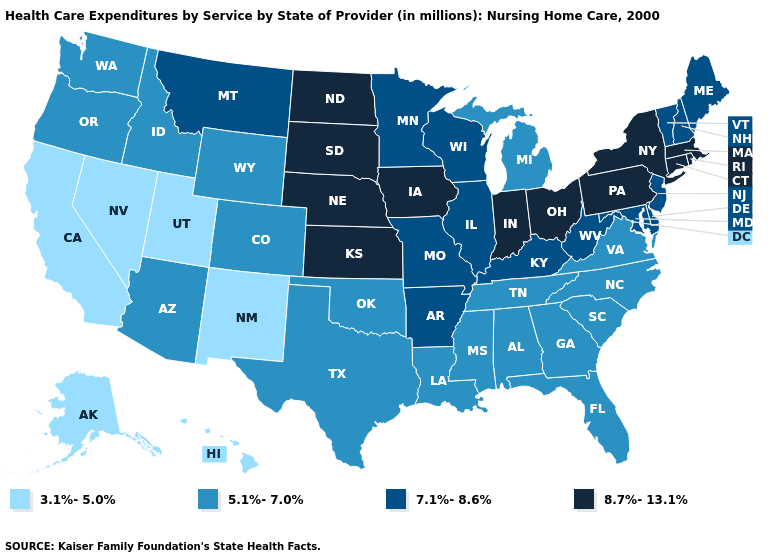How many symbols are there in the legend?
Keep it brief. 4. What is the value of South Dakota?
Concise answer only. 8.7%-13.1%. Does the map have missing data?
Quick response, please. No. Name the states that have a value in the range 8.7%-13.1%?
Keep it brief. Connecticut, Indiana, Iowa, Kansas, Massachusetts, Nebraska, New York, North Dakota, Ohio, Pennsylvania, Rhode Island, South Dakota. What is the value of Alaska?
Be succinct. 3.1%-5.0%. What is the highest value in the MidWest ?
Write a very short answer. 8.7%-13.1%. Does the first symbol in the legend represent the smallest category?
Give a very brief answer. Yes. Does the map have missing data?
Concise answer only. No. Does Rhode Island have the same value as North Carolina?
Quick response, please. No. Among the states that border Virginia , which have the lowest value?
Keep it brief. North Carolina, Tennessee. Name the states that have a value in the range 7.1%-8.6%?
Write a very short answer. Arkansas, Delaware, Illinois, Kentucky, Maine, Maryland, Minnesota, Missouri, Montana, New Hampshire, New Jersey, Vermont, West Virginia, Wisconsin. Name the states that have a value in the range 7.1%-8.6%?
Answer briefly. Arkansas, Delaware, Illinois, Kentucky, Maine, Maryland, Minnesota, Missouri, Montana, New Hampshire, New Jersey, Vermont, West Virginia, Wisconsin. Does the map have missing data?
Concise answer only. No. What is the value of Arizona?
Quick response, please. 5.1%-7.0%. Among the states that border Georgia , which have the highest value?
Quick response, please. Alabama, Florida, North Carolina, South Carolina, Tennessee. 